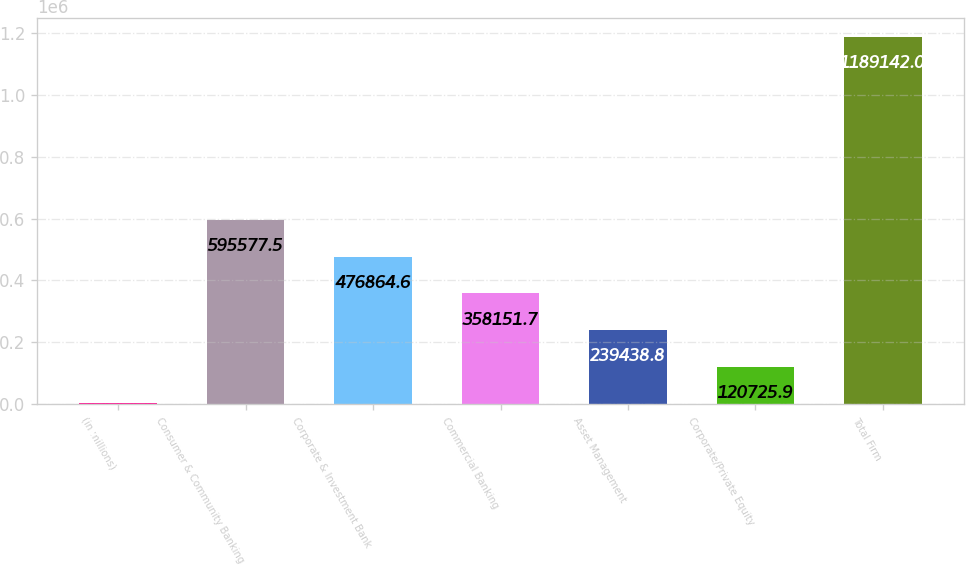<chart> <loc_0><loc_0><loc_500><loc_500><bar_chart><fcel>(in millions)<fcel>Consumer & Community Banking<fcel>Corporate & Investment Bank<fcel>Commercial Banking<fcel>Asset Management<fcel>Corporate/Private Equity<fcel>Total Firm<nl><fcel>2013<fcel>595578<fcel>476865<fcel>358152<fcel>239439<fcel>120726<fcel>1.18914e+06<nl></chart> 